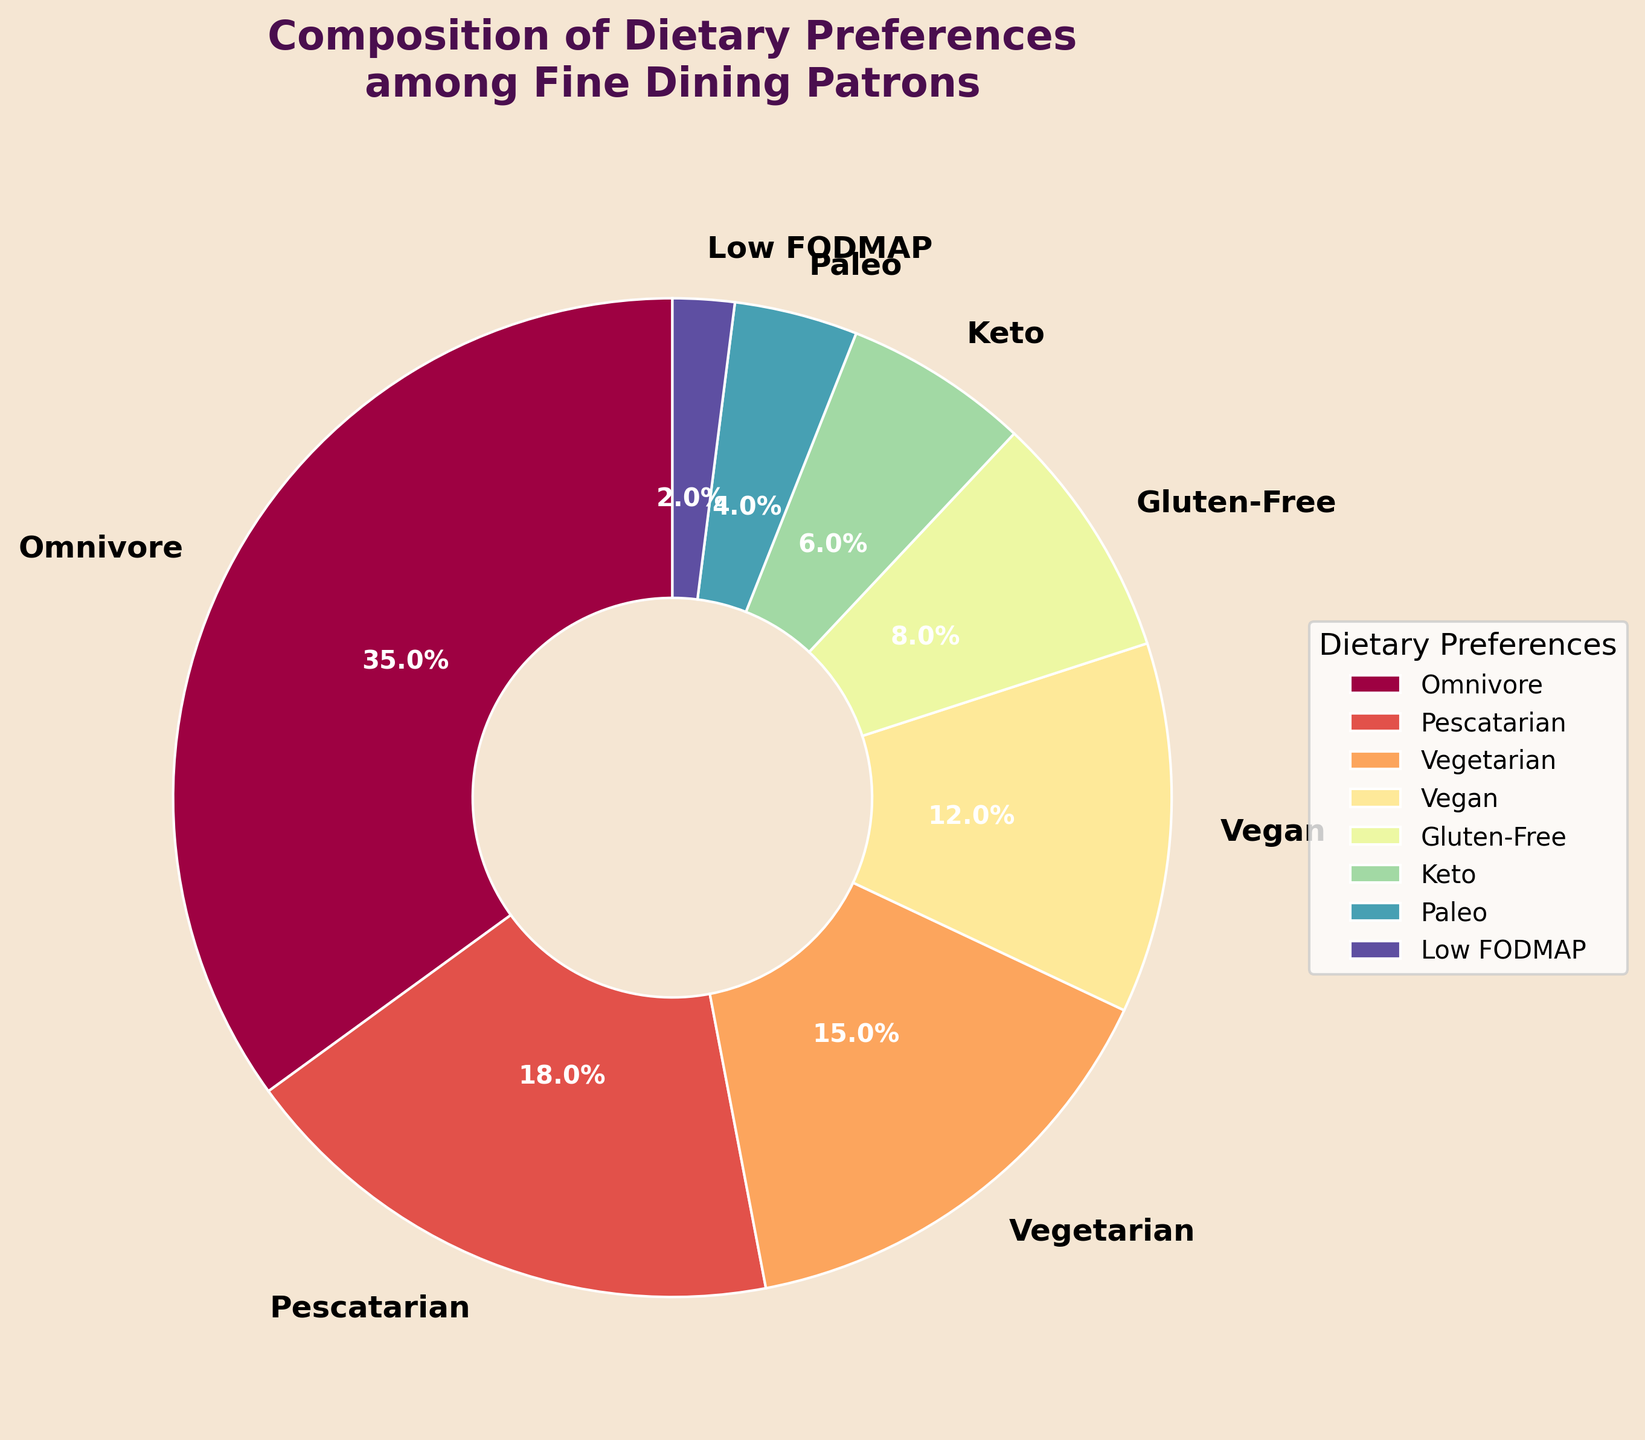What's the most common dietary preference among fine dining patrons? The most common dietary preference is the one with the highest percentage. From the data, Omnivore has the highest percentage at 35%.
Answer: Omnivore What's the combined percentage of Vegan and Vegetarian patrons? To find the combined percentage, add the percentages of Vegan (12%) and Vegetarian (15%) patrons: 12% + 15% = 27%.
Answer: 27% Which dietary preference has the smallest representation? The dietary preference with the smallest representation is the one with the lowest percentage. From the data, Low FODMAP has the smallest percentage at 2%.
Answer: Low FODMAP How do the percentages of Gluten-Free and Keto patrons compare? Compare the percentages of Gluten-Free (8%) and Keto (6%) patrons. Since 8% is greater than 6%, Gluten-Free has a higher percentage.
Answer: Gluten-Free > Keto Is the percentage of Pescatarian patrons greater than the combined percentage of Paleo and Low FODMAP patrons? First, sum the percentages of Paleo (4%) and Low FODMAP (2%) patrons: 4% + 2% = 6%. Pescatarian has 18%, which is greater than 6%.
Answer: Yes What is the percentage difference between Omnivore and Vegan patrons? Subtract the percentage of Vegan (12%) from Omnivore (35%): 35% - 12% = 23%.
Answer: 23% Which dietary preferences have a higher percentage than Gluten-Free but lower than Omnivore? Examine the percentages: Omnivore (35%), Pescatarian (18%), and Vegetarian (15%) are higher than Gluten-Free (8%) but lower than Omnivore.
Answer: Pescatarian and Vegetarian What is the total percentage of patrons following low-carbohydrate diets (Keto and Paleo)? Add the percentages of Keto (6%) and Paleo (4%) diets: 6% + 4% = 10%.
Answer: 10% How does the representation of Vegetarian patrons compare to that of Omnivore and Vegan patrons combined? Combine Omnivore and Vegan: 35% + 12% = 47%. Compare to Vegetarian (15%); 47% > 15%.
Answer: Fewer Which section of the pie chart is colored most closely to the center hue on the color spectrum? The pie chart sections are colored using the Spectral colormap, which transitions from red to blue. To identify the color closest to the center of the spectrum, focus on the middle values which are likely to have an intermediate hue such as green or yellow. Let's assume central hues (yellow/green) typically represent medium values. E.g., sizes 8% (Gluten-Free), 12% (Vegan), 15% (Vegetarian), 18% (Pescatarian). Gluten-Free (8%) may be closely centered.
Answer: Gluten-Free 